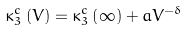Convert formula to latex. <formula><loc_0><loc_0><loc_500><loc_500>\kappa _ { 3 } ^ { c } \left ( V \right ) = \kappa _ { 3 } ^ { c } \left ( \infty \right ) + a V ^ { - \delta }</formula> 